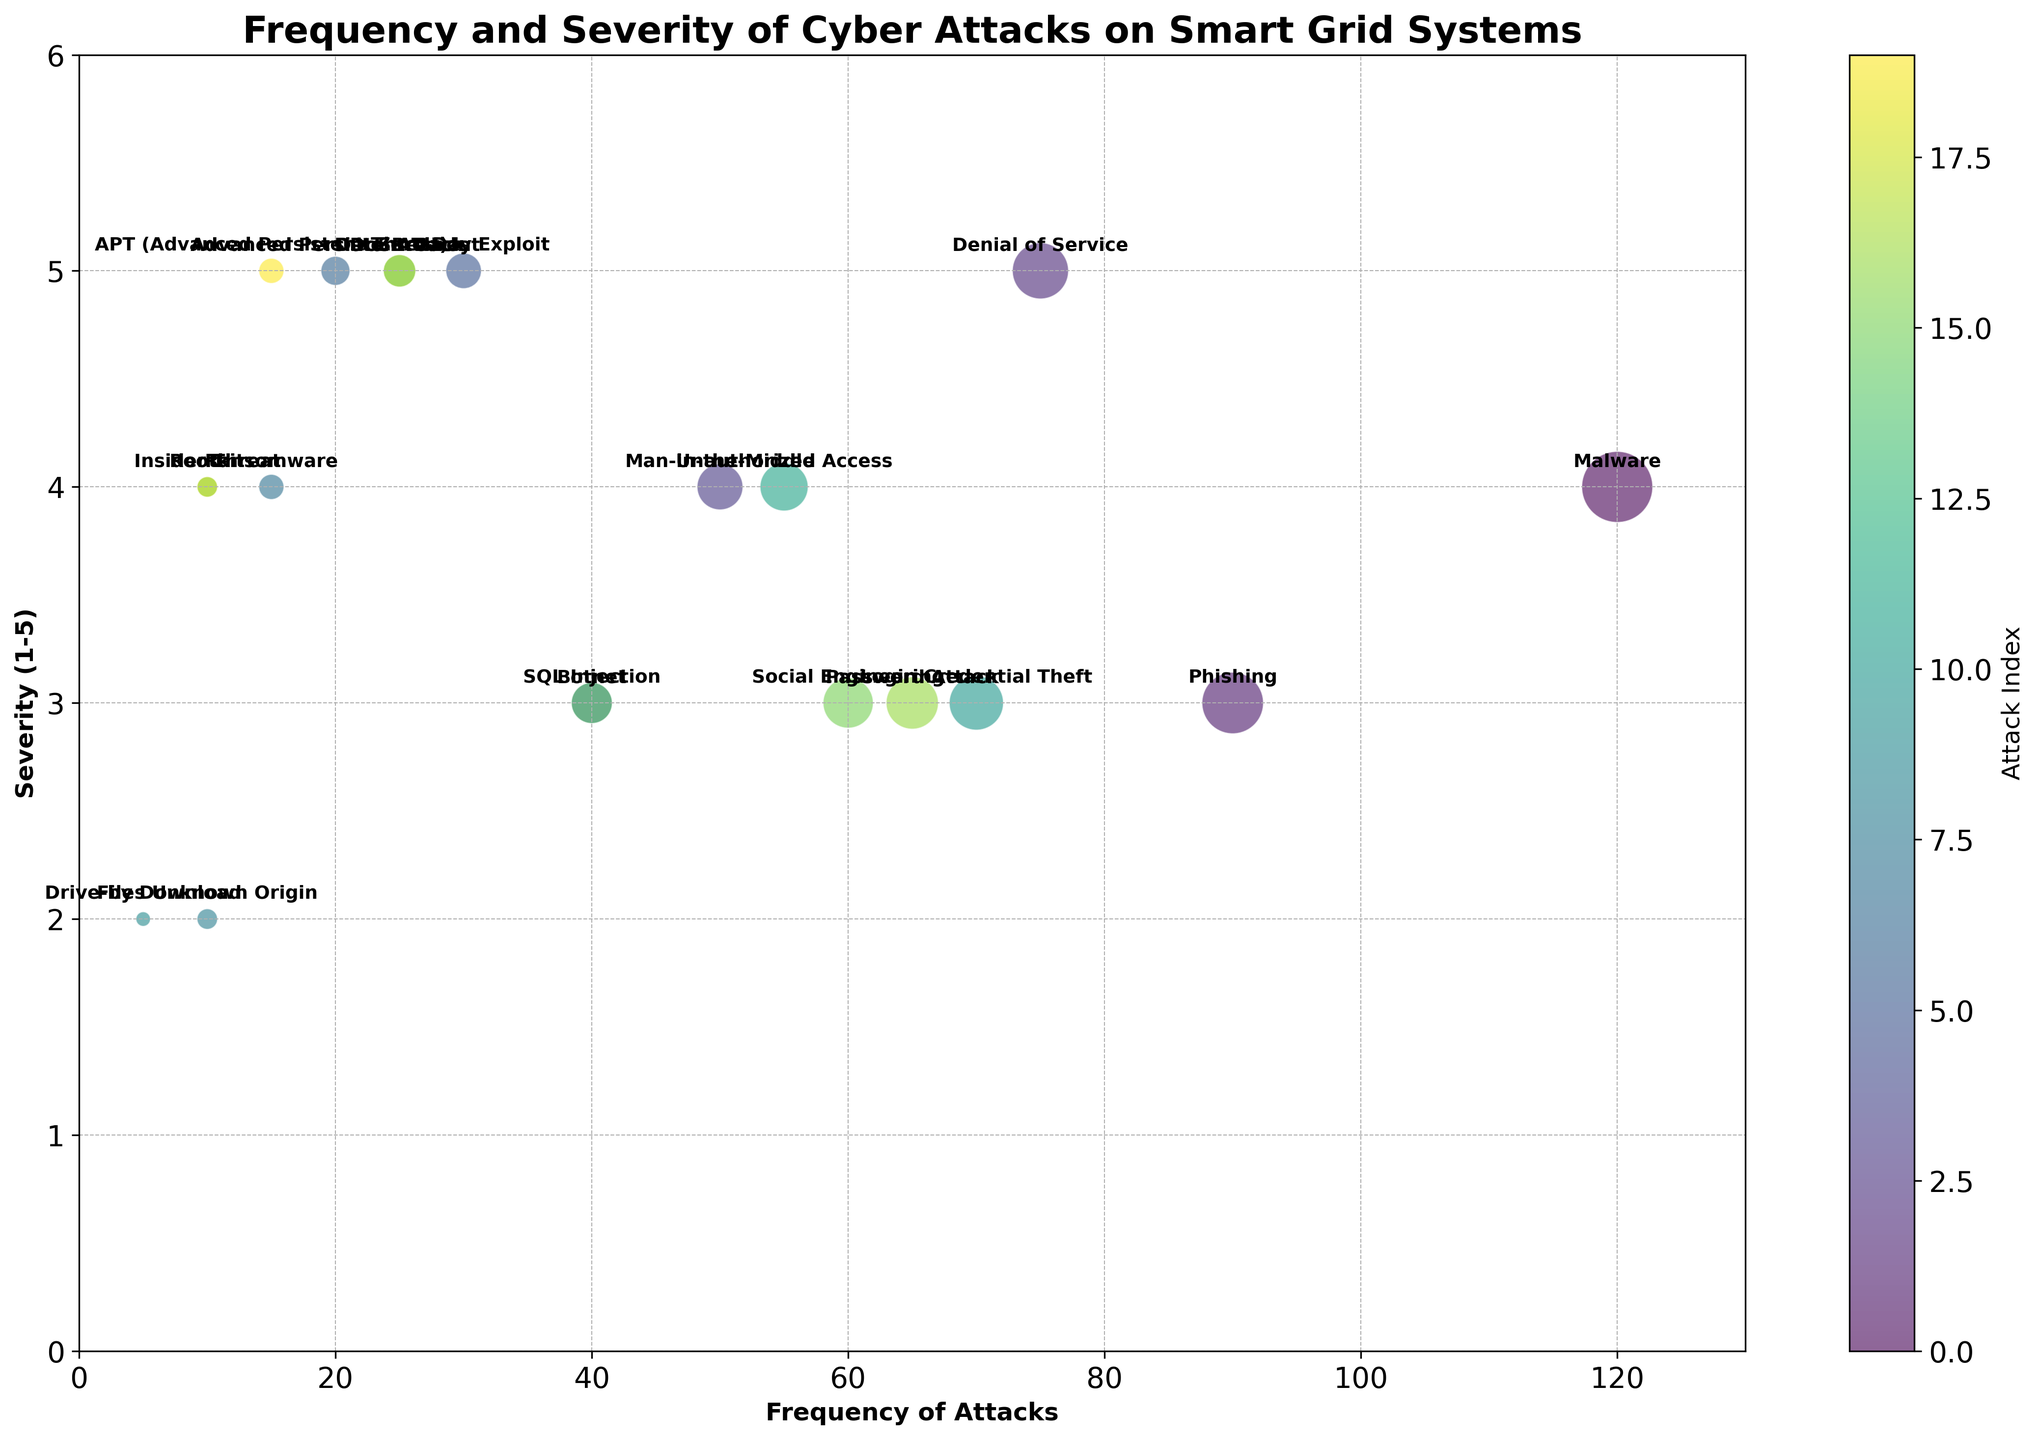What is the most frequent type of cyber attack on smart grid systems? The bubble with the highest frequency value will represent the most frequent attack type. In the plot, "Malware" has the highest frequency value of 120.
Answer: Malware Which cyber attack has the highest severity, and what is its frequency? The bubble positioned at the highest severity level (5) with the corresponding attack label indicates the attack with the highest severity. Both "Denial of Service," "Zero-Day Exploit," "Advanced Persistent Threat," "Data Breach," and "DDoS Attack" have the highest severity of 5. Among them, "Denial of Service" has the highest frequency value of 75.
Answer: Denial of Service, 75 Compare the frequency of social engineering attacks to insider threats. Which is more frequent? Locate and compare the frequency values of "Social Engineering" and "Insider Threat." The frequency of "Social Engineering" is 60, while that of "Insider Threat" is 10. Since 60 > 10, "Social Engineering" is more frequent.
Answer: Social Engineering What's the average frequency of attacks that have a severity of 4? Identify the attacks with severity 4: "Malware" (120), "Man-in-the-Middle" (50), "Unauthorized Access" (55), "Ransomware" (15), "Insider Threat" (10), and "Rootkit" (10). Sum these frequencies: 120 + 50 + 55 + 15 + 10 + 10 = 260. There are 6 attacks, so the average is 260 / 6 = 43.33.
Answer: 43.33 Which attack type among "Phishing," "Unauthorized Access," and "SQL Injection" has the highest severity? Compare the severity levels of "Phishing" (3), "Unauthorized Access" (4), and "SQL Injection" (3). The highest severity level among them is 4 for "Unauthorized Access."
Answer: Unauthorized Access How does the frequency of "Drive-by Download" compare to "Files Unknown Origin"? Review the frequency values of both: "Drive-by Download" has a frequency of 5, while "Files Unknown Origin" has 10. Since 10 > 5, "Files Unknown Origin" is more frequent.
Answer: Files Unknown Origin Calculate the difference in frequency between the most and the least frequent attack types. The most frequent attack type is "Malware" with a frequency of 120. The least frequent attack type is "Drive-by Download" with a frequency of 5. The difference is 120 - 5 = 115.
Answer: 115 Which types of attacks on the chart have a frequency between 25 and 65? Identify the attacks within the given frequency range: "Login Credential Theft" (70) is above the range; the attacks meeting this condition include "Denial of Service" (75) is also above the range but "SQL Injection" (40), "Insider Threat" (10) and "Drive-by Download" (5) are below the range. Therefore, types within that range are "Data Breach" (25) and "Social Engineering" (60), and "Password Attack" (65).
Answer: Data Breach, Social Engineering, Password Attack Which cyber attack with a severity of 3 has the lowest frequency? Among the attacks with severity 3, compare their frequencies: "Phishing" (90), "SQL Injection" (40), "Botnet" (40), "Social Engineering" (60), and "Password Attack" (65). Here, "SQL Injection" and "Botnet" both have the lowest frequency of 40.
Answer: SQL Injection and Botnet 